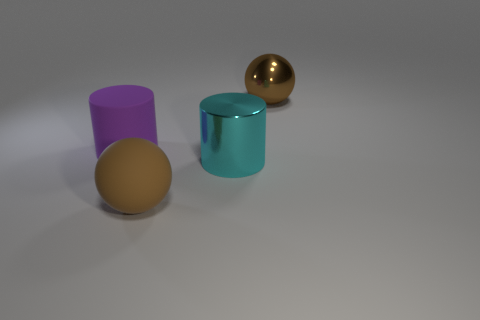Add 3 small yellow metal things. How many objects exist? 7 Add 4 large brown rubber things. How many large brown rubber things are left? 5 Add 2 small green balls. How many small green balls exist? 2 Subtract 0 brown cylinders. How many objects are left? 4 Subtract all large rubber spheres. Subtract all large purple matte things. How many objects are left? 2 